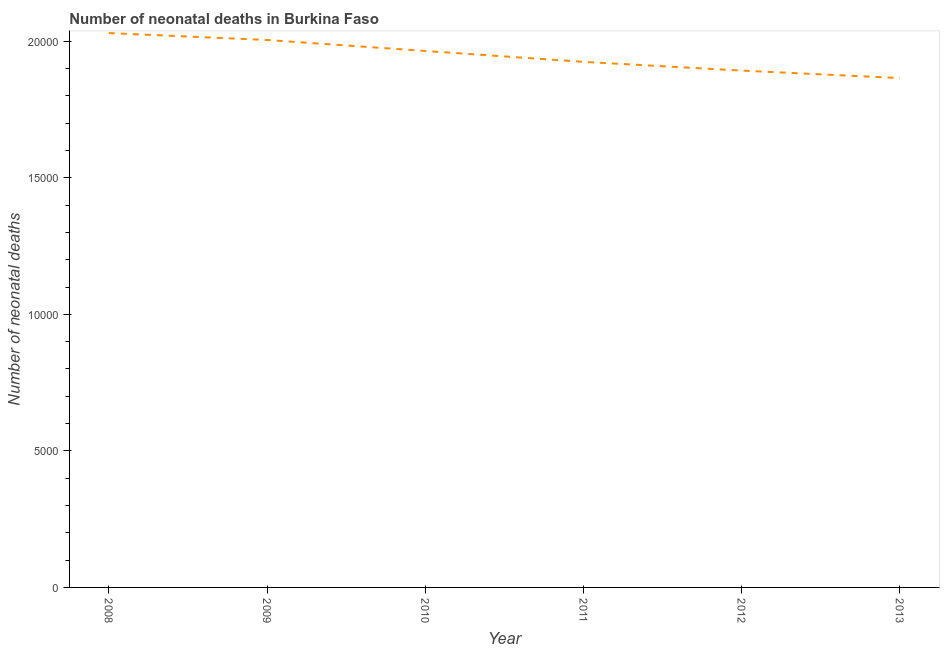What is the number of neonatal deaths in 2010?
Your answer should be compact. 1.96e+04. Across all years, what is the maximum number of neonatal deaths?
Provide a short and direct response. 2.03e+04. Across all years, what is the minimum number of neonatal deaths?
Make the answer very short. 1.87e+04. In which year was the number of neonatal deaths maximum?
Provide a short and direct response. 2008. In which year was the number of neonatal deaths minimum?
Ensure brevity in your answer.  2013. What is the sum of the number of neonatal deaths?
Provide a short and direct response. 1.17e+05. What is the difference between the number of neonatal deaths in 2009 and 2010?
Provide a short and direct response. 402. What is the average number of neonatal deaths per year?
Your response must be concise. 1.95e+04. What is the median number of neonatal deaths?
Make the answer very short. 1.94e+04. In how many years, is the number of neonatal deaths greater than 17000 ?
Make the answer very short. 6. What is the ratio of the number of neonatal deaths in 2012 to that in 2013?
Make the answer very short. 1.01. Is the difference between the number of neonatal deaths in 2011 and 2013 greater than the difference between any two years?
Your answer should be compact. No. What is the difference between the highest and the second highest number of neonatal deaths?
Keep it short and to the point. 253. Is the sum of the number of neonatal deaths in 2008 and 2009 greater than the maximum number of neonatal deaths across all years?
Your answer should be compact. Yes. What is the difference between the highest and the lowest number of neonatal deaths?
Ensure brevity in your answer.  1648. In how many years, is the number of neonatal deaths greater than the average number of neonatal deaths taken over all years?
Your response must be concise. 3. How many years are there in the graph?
Keep it short and to the point. 6. What is the difference between two consecutive major ticks on the Y-axis?
Provide a short and direct response. 5000. Does the graph contain grids?
Offer a very short reply. No. What is the title of the graph?
Your answer should be very brief. Number of neonatal deaths in Burkina Faso. What is the label or title of the Y-axis?
Offer a terse response. Number of neonatal deaths. What is the Number of neonatal deaths in 2008?
Offer a very short reply. 2.03e+04. What is the Number of neonatal deaths in 2009?
Keep it short and to the point. 2.00e+04. What is the Number of neonatal deaths of 2010?
Offer a very short reply. 1.96e+04. What is the Number of neonatal deaths of 2011?
Provide a short and direct response. 1.92e+04. What is the Number of neonatal deaths of 2012?
Ensure brevity in your answer.  1.89e+04. What is the Number of neonatal deaths of 2013?
Your answer should be very brief. 1.87e+04. What is the difference between the Number of neonatal deaths in 2008 and 2009?
Give a very brief answer. 253. What is the difference between the Number of neonatal deaths in 2008 and 2010?
Offer a terse response. 655. What is the difference between the Number of neonatal deaths in 2008 and 2011?
Your response must be concise. 1054. What is the difference between the Number of neonatal deaths in 2008 and 2012?
Ensure brevity in your answer.  1374. What is the difference between the Number of neonatal deaths in 2008 and 2013?
Provide a short and direct response. 1648. What is the difference between the Number of neonatal deaths in 2009 and 2010?
Provide a succinct answer. 402. What is the difference between the Number of neonatal deaths in 2009 and 2011?
Keep it short and to the point. 801. What is the difference between the Number of neonatal deaths in 2009 and 2012?
Offer a terse response. 1121. What is the difference between the Number of neonatal deaths in 2009 and 2013?
Ensure brevity in your answer.  1395. What is the difference between the Number of neonatal deaths in 2010 and 2011?
Provide a succinct answer. 399. What is the difference between the Number of neonatal deaths in 2010 and 2012?
Your answer should be very brief. 719. What is the difference between the Number of neonatal deaths in 2010 and 2013?
Provide a short and direct response. 993. What is the difference between the Number of neonatal deaths in 2011 and 2012?
Your answer should be compact. 320. What is the difference between the Number of neonatal deaths in 2011 and 2013?
Your answer should be very brief. 594. What is the difference between the Number of neonatal deaths in 2012 and 2013?
Your answer should be very brief. 274. What is the ratio of the Number of neonatal deaths in 2008 to that in 2009?
Your answer should be very brief. 1.01. What is the ratio of the Number of neonatal deaths in 2008 to that in 2010?
Your answer should be very brief. 1.03. What is the ratio of the Number of neonatal deaths in 2008 to that in 2011?
Ensure brevity in your answer.  1.05. What is the ratio of the Number of neonatal deaths in 2008 to that in 2012?
Provide a short and direct response. 1.07. What is the ratio of the Number of neonatal deaths in 2008 to that in 2013?
Provide a short and direct response. 1.09. What is the ratio of the Number of neonatal deaths in 2009 to that in 2010?
Your answer should be very brief. 1.02. What is the ratio of the Number of neonatal deaths in 2009 to that in 2011?
Provide a short and direct response. 1.04. What is the ratio of the Number of neonatal deaths in 2009 to that in 2012?
Offer a very short reply. 1.06. What is the ratio of the Number of neonatal deaths in 2009 to that in 2013?
Offer a terse response. 1.07. What is the ratio of the Number of neonatal deaths in 2010 to that in 2011?
Ensure brevity in your answer.  1.02. What is the ratio of the Number of neonatal deaths in 2010 to that in 2012?
Keep it short and to the point. 1.04. What is the ratio of the Number of neonatal deaths in 2010 to that in 2013?
Offer a very short reply. 1.05. What is the ratio of the Number of neonatal deaths in 2011 to that in 2012?
Give a very brief answer. 1.02. What is the ratio of the Number of neonatal deaths in 2011 to that in 2013?
Your answer should be compact. 1.03. What is the ratio of the Number of neonatal deaths in 2012 to that in 2013?
Keep it short and to the point. 1.01. 